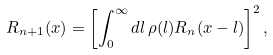Convert formula to latex. <formula><loc_0><loc_0><loc_500><loc_500>R _ { n + 1 } ( x ) = \left [ \int _ { 0 } ^ { \infty } d l \, \rho ( l ) R _ { n } ( x - l ) \right ] ^ { 2 } ,</formula> 